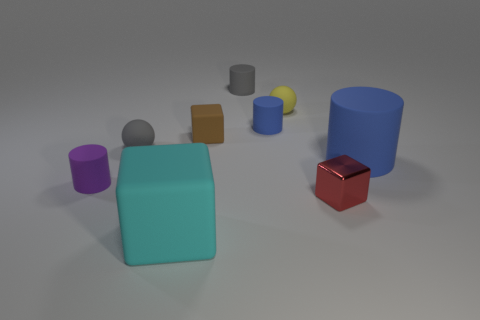What number of large things are matte objects or green metallic spheres?
Give a very brief answer. 2. There is a large object on the left side of the small block that is on the right side of the yellow thing; is there a purple matte cylinder in front of it?
Ensure brevity in your answer.  No. Are there any cyan matte cubes that have the same size as the yellow matte ball?
Your response must be concise. No. What material is the purple cylinder that is the same size as the gray cylinder?
Provide a succinct answer. Rubber. There is a cyan cube; is its size the same as the ball in front of the tiny yellow object?
Make the answer very short. No. What number of matte things are blue cylinders or big cyan cubes?
Your answer should be compact. 3. How many tiny purple things are the same shape as the tiny blue matte object?
Give a very brief answer. 1. What is the material of the other cylinder that is the same color as the big cylinder?
Offer a very short reply. Rubber. There is a blue thing that is behind the small brown block; does it have the same size as the gray thing in front of the tiny yellow rubber object?
Ensure brevity in your answer.  Yes. There is a gray matte thing right of the cyan rubber block; what shape is it?
Give a very brief answer. Cylinder. 